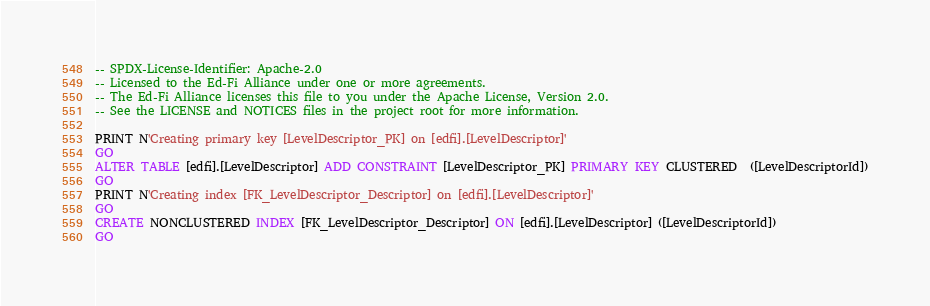<code> <loc_0><loc_0><loc_500><loc_500><_SQL_>-- SPDX-License-Identifier: Apache-2.0
-- Licensed to the Ed-Fi Alliance under one or more agreements.
-- The Ed-Fi Alliance licenses this file to you under the Apache License, Version 2.0.
-- See the LICENSE and NOTICES files in the project root for more information.

PRINT N'Creating primary key [LevelDescriptor_PK] on [edfi].[LevelDescriptor]'
GO
ALTER TABLE [edfi].[LevelDescriptor] ADD CONSTRAINT [LevelDescriptor_PK] PRIMARY KEY CLUSTERED  ([LevelDescriptorId])
GO
PRINT N'Creating index [FK_LevelDescriptor_Descriptor] on [edfi].[LevelDescriptor]'
GO
CREATE NONCLUSTERED INDEX [FK_LevelDescriptor_Descriptor] ON [edfi].[LevelDescriptor] ([LevelDescriptorId])
GO

</code> 